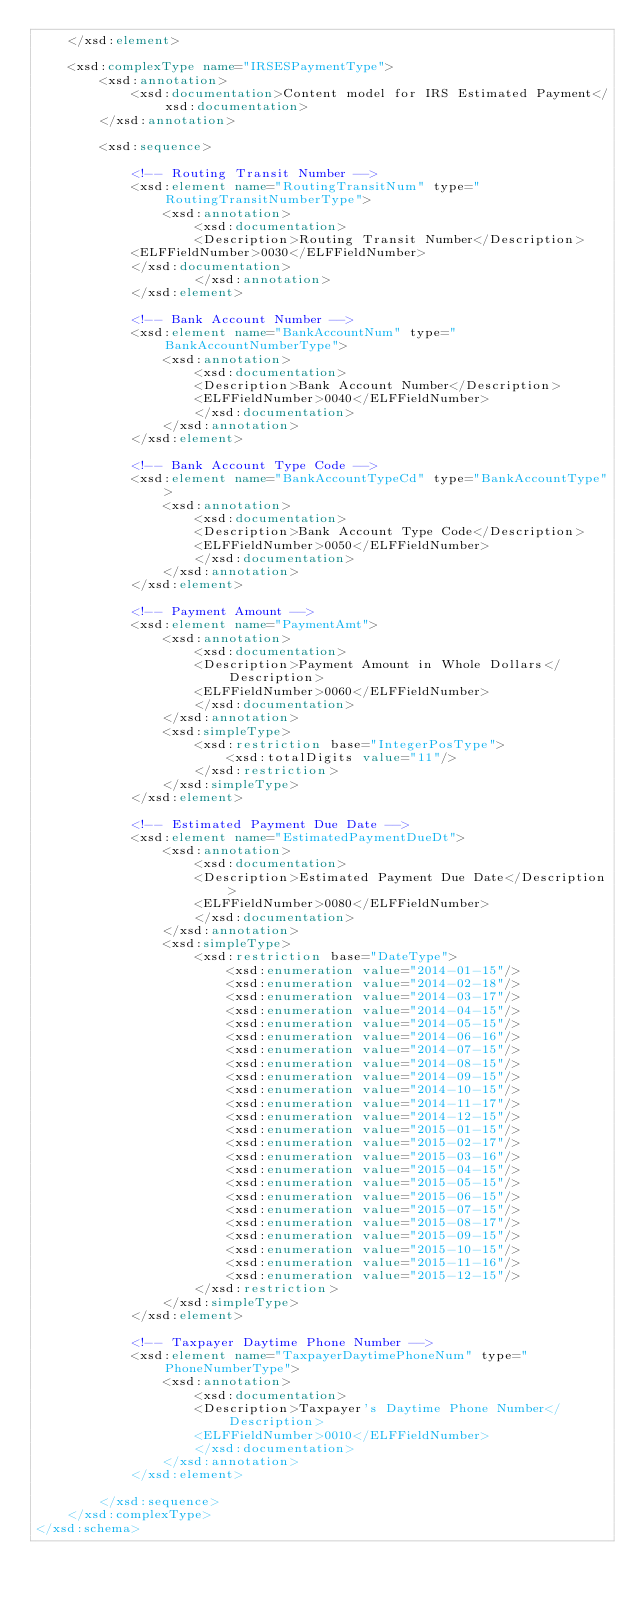<code> <loc_0><loc_0><loc_500><loc_500><_XML_>	</xsd:element>

	<xsd:complexType name="IRSESPaymentType">
		<xsd:annotation>
			<xsd:documentation>Content model for IRS Estimated Payment</xsd:documentation>
		</xsd:annotation>

		<xsd:sequence>

			<!-- Routing Transit Number -->
			<xsd:element name="RoutingTransitNum" type="RoutingTransitNumberType">
				<xsd:annotation>
					<xsd:documentation>
					<Description>Routing Transit Number</Description>
			<ELFFieldNumber>0030</ELFFieldNumber>
			</xsd:documentation>
					</xsd:annotation>
			</xsd:element>

			<!-- Bank Account Number -->
			<xsd:element name="BankAccountNum" type="BankAccountNumberType">
				<xsd:annotation>
					<xsd:documentation>
					<Description>Bank Account Number</Description>
					<ELFFieldNumber>0040</ELFFieldNumber>
					</xsd:documentation>
				</xsd:annotation>
			</xsd:element>

			<!-- Bank Account Type Code -->
			<xsd:element name="BankAccountTypeCd" type="BankAccountType">
				<xsd:annotation>
					<xsd:documentation>
					<Description>Bank Account Type Code</Description>
					<ELFFieldNumber>0050</ELFFieldNumber>
					</xsd:documentation>
				</xsd:annotation>
			</xsd:element>

			<!-- Payment Amount -->
			<xsd:element name="PaymentAmt">
				<xsd:annotation>
					<xsd:documentation>
					<Description>Payment Amount in Whole Dollars</Description>
					<ELFFieldNumber>0060</ELFFieldNumber>
					</xsd:documentation>
				</xsd:annotation>
				<xsd:simpleType>
					<xsd:restriction base="IntegerPosType">
						<xsd:totalDigits value="11"/>
					</xsd:restriction>
				</xsd:simpleType>
			</xsd:element>

			<!-- Estimated Payment Due Date -->
			<xsd:element name="EstimatedPaymentDueDt">
				<xsd:annotation>
					<xsd:documentation>
					<Description>Estimated Payment Due Date</Description>
					<ELFFieldNumber>0080</ELFFieldNumber>
					</xsd:documentation>
				</xsd:annotation>
				<xsd:simpleType>
					<xsd:restriction base="DateType">
						<xsd:enumeration value="2014-01-15"/>
						<xsd:enumeration value="2014-02-18"/>
						<xsd:enumeration value="2014-03-17"/>
						<xsd:enumeration value="2014-04-15"/>
						<xsd:enumeration value="2014-05-15"/>
						<xsd:enumeration value="2014-06-16"/>
						<xsd:enumeration value="2014-07-15"/>
						<xsd:enumeration value="2014-08-15"/>
						<xsd:enumeration value="2014-09-15"/>
						<xsd:enumeration value="2014-10-15"/>
						<xsd:enumeration value="2014-11-17"/>
						<xsd:enumeration value="2014-12-15"/>
						<xsd:enumeration value="2015-01-15"/>
						<xsd:enumeration value="2015-02-17"/>
						<xsd:enumeration value="2015-03-16"/>
						<xsd:enumeration value="2015-04-15"/>
						<xsd:enumeration value="2015-05-15"/>
						<xsd:enumeration value="2015-06-15"/>
						<xsd:enumeration value="2015-07-15"/>
						<xsd:enumeration value="2015-08-17"/>
						<xsd:enumeration value="2015-09-15"/>
						<xsd:enumeration value="2015-10-15"/>
						<xsd:enumeration value="2015-11-16"/>
						<xsd:enumeration value="2015-12-15"/>
					</xsd:restriction>
				</xsd:simpleType>
			</xsd:element>

			<!-- Taxpayer Daytime Phone Number -->
			<xsd:element name="TaxpayerDaytimePhoneNum" type="PhoneNumberType">
				<xsd:annotation>
					<xsd:documentation>
					<Description>Taxpayer's Daytime Phone Number</Description>
					<ELFFieldNumber>0010</ELFFieldNumber>
					</xsd:documentation>
				</xsd:annotation>
			</xsd:element>

		</xsd:sequence>
	</xsd:complexType>
</xsd:schema>
</code> 